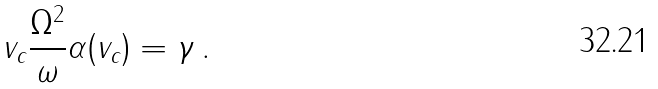Convert formula to latex. <formula><loc_0><loc_0><loc_500><loc_500>v _ { c } \frac { \Omega ^ { 2 } } { \omega } \alpha ( v _ { c } ) = \gamma \, .</formula> 